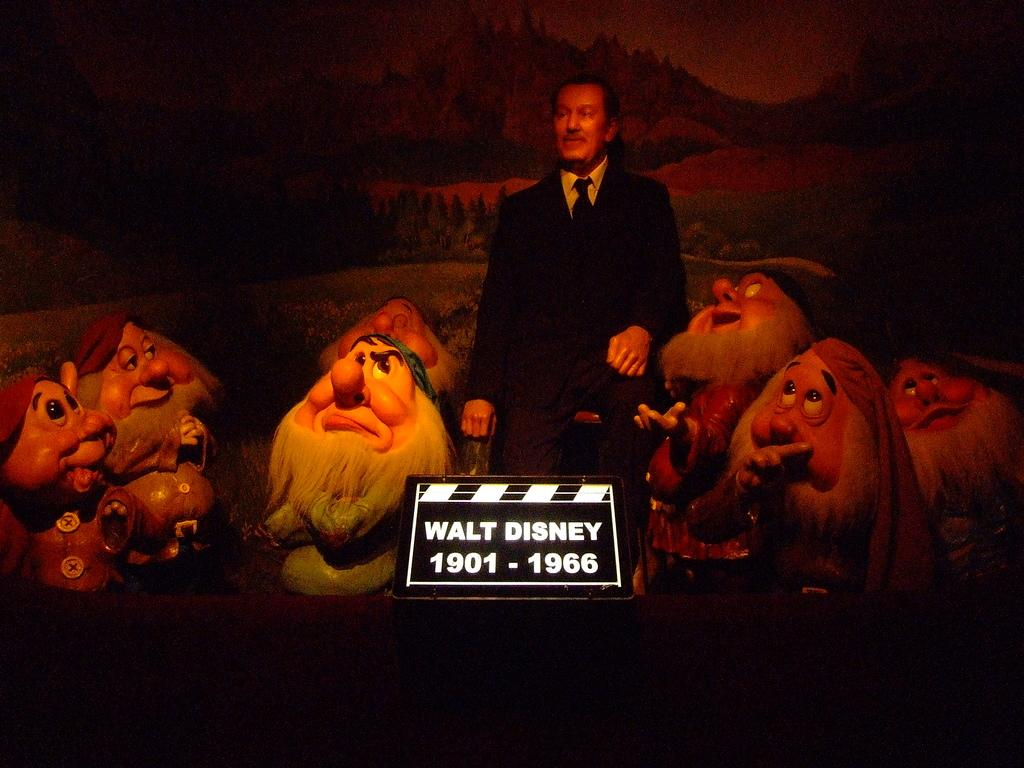What is on the board that is visible in the image? There is text on the board in the image. What is the man in the image doing? The man is sitting in the middle of the image. What objects are on either side of the man? There are dolls on either side of the man. How many trains can be seen in the image? There are no trains present in the image. What type of card is the man holding in the image? The man is not holding a card in the image. 